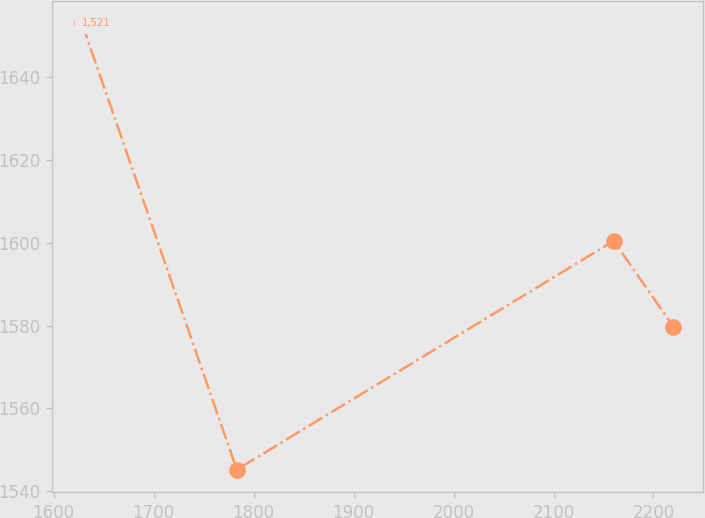<chart> <loc_0><loc_0><loc_500><loc_500><line_chart><ecel><fcel>1,521<nl><fcel>1628.31<fcel>1653.03<nl><fcel>1783.24<fcel>1545.2<nl><fcel>2160.21<fcel>1600.47<nl><fcel>2219.99<fcel>1579.7<nl></chart> 